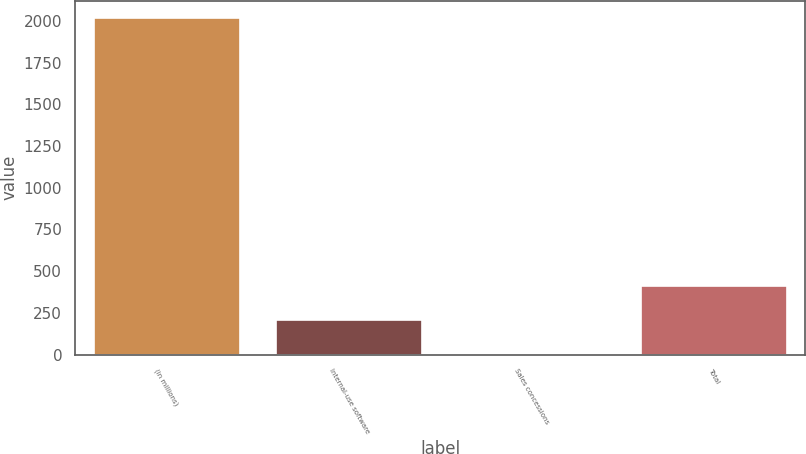Convert chart. <chart><loc_0><loc_0><loc_500><loc_500><bar_chart><fcel>(in millions)<fcel>Internal-use software<fcel>Sales concessions<fcel>Total<nl><fcel>2019<fcel>207.3<fcel>6<fcel>408.6<nl></chart> 